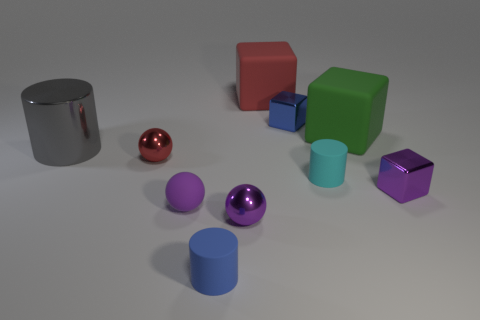There is a red object in front of the small shiny cube that is on the left side of the shiny cube in front of the metal cylinder; what is its material?
Provide a short and direct response. Metal. There is a red thing that is behind the green rubber thing; does it have the same size as the large cylinder?
Offer a terse response. Yes. Are there more tiny purple shiny cubes than small purple metallic cylinders?
Make the answer very short. Yes. What number of small objects are either metallic spheres or brown metal cylinders?
Your response must be concise. 2. What number of other objects are there of the same color as the matte sphere?
Make the answer very short. 2. What number of large gray cylinders have the same material as the cyan object?
Your response must be concise. 0. There is a tiny block that is right of the green matte block; is it the same color as the tiny rubber ball?
Offer a terse response. Yes. How many green objects are either matte spheres or matte objects?
Offer a terse response. 1. Is the cylinder in front of the purple rubber ball made of the same material as the small cyan cylinder?
Provide a succinct answer. Yes. What number of objects are balls or blue things that are in front of the metal cylinder?
Ensure brevity in your answer.  4. 